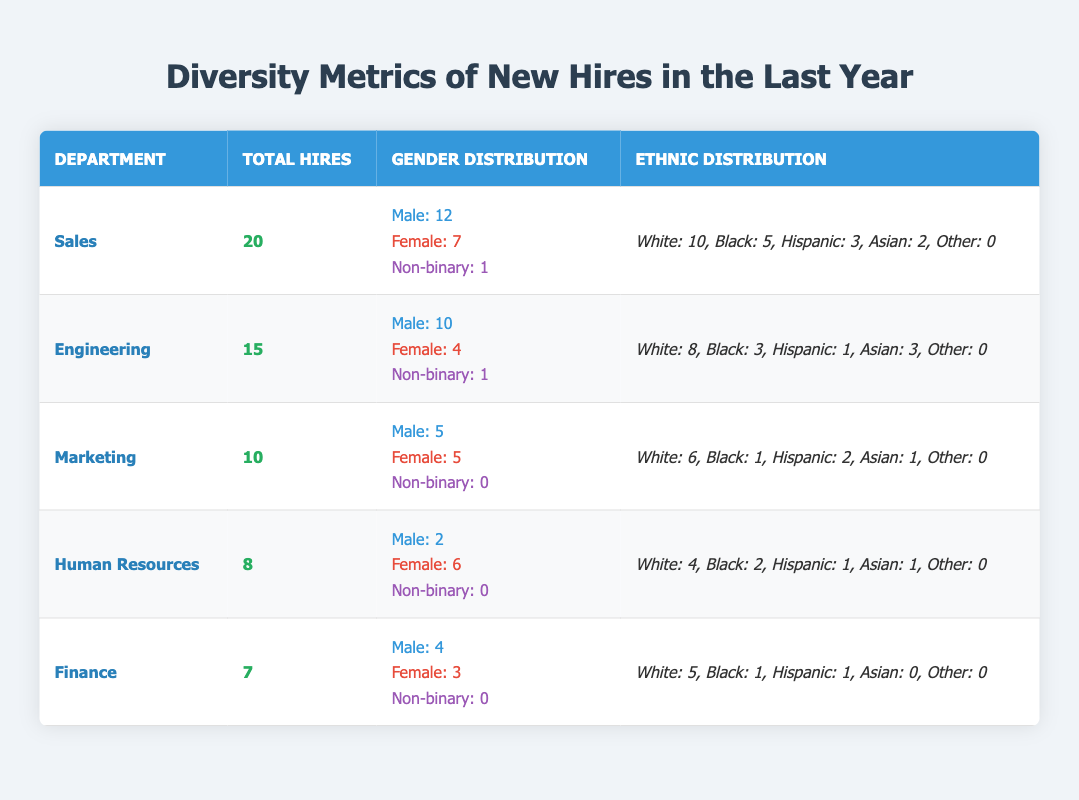What is the total number of new hires in the Sales department? According to the table, the total hires in the Sales department are listed as 20.
Answer: 20 How many female employees were hired in the Human Resources department? The table indicates that 6 females were hired in the Human Resources department.
Answer: 6 What department had the highest total number of new hires? By comparing the total hires across departments, Sales has 20 hires, which is the highest compared to others.
Answer: Sales Which department has the lowest number of hires? By examining the total hires, Finance has the lowest total with 7 hires.
Answer: Finance How many more male hires are there in Engineering compared to Marketing? Engineering has 10 male hires and Marketing has 5 male hires, so 10 - 5 = 5 more male hires in Engineering.
Answer: 5 What percentage of total hires in the Sales department are male? The total hires in Sales is 20 and there are 12 male hires. Thus, (12/20) * 100 = 60%.
Answer: 60% Are there any new hires classified as 'Other' in the Hispanic ethnicity category across all departments? The table shows that 'Other' categorized hires are all 0 across all departments.
Answer: No What is the total number of non-binary hires across all departments? Summing the non-binary hires gives 1 (Sales) + 1 (Engineering) + 0 (Marketing) + 0 (Human Resources) + 0 (Finance) = 2.
Answer: 2 Which department has the highest diversity in terms of gender among new hires? Looking at gender representation, Marketing has an equal distribution with 5 males and 5 females, indicating higher diversity compared to others.
Answer: Marketing If we consider only the Black hires, which departments have a total of 6 or more Black hires? The Black hires counted are 5 (Sales) + 3 (Engineering) + 1 (Marketing) + 2 (Human Resources) + 1 (Finance) = 12 total. However, no single department has 6 or more; the maximum is 5 in Sales.
Answer: No 